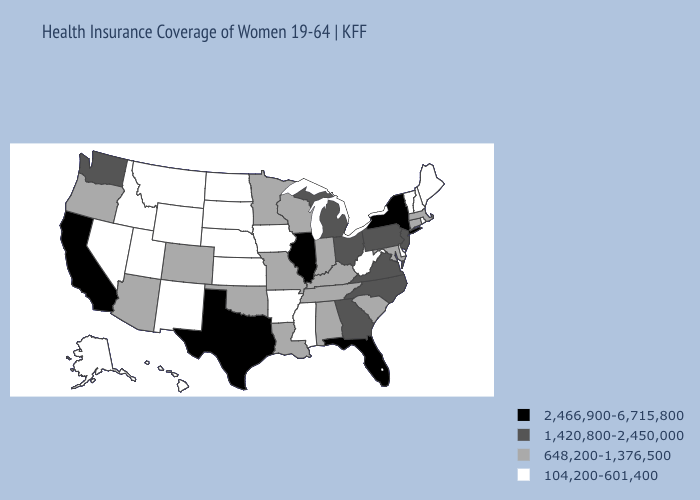Among the states that border Maryland , which have the lowest value?
Concise answer only. Delaware, West Virginia. Does Alabama have a higher value than Louisiana?
Be succinct. No. Name the states that have a value in the range 1,420,800-2,450,000?
Answer briefly. Georgia, Michigan, New Jersey, North Carolina, Ohio, Pennsylvania, Virginia, Washington. Name the states that have a value in the range 2,466,900-6,715,800?
Keep it brief. California, Florida, Illinois, New York, Texas. Does California have the highest value in the West?
Short answer required. Yes. Does Missouri have a higher value than South Dakota?
Write a very short answer. Yes. What is the value of Minnesota?
Quick response, please. 648,200-1,376,500. Does Pennsylvania have a lower value than New Mexico?
Quick response, please. No. What is the value of Colorado?
Give a very brief answer. 648,200-1,376,500. Among the states that border Georgia , does North Carolina have the highest value?
Write a very short answer. No. What is the value of North Carolina?
Be succinct. 1,420,800-2,450,000. What is the value of Maine?
Keep it brief. 104,200-601,400. What is the lowest value in the MidWest?
Be succinct. 104,200-601,400. What is the value of Illinois?
Short answer required. 2,466,900-6,715,800. What is the value of Kansas?
Quick response, please. 104,200-601,400. 